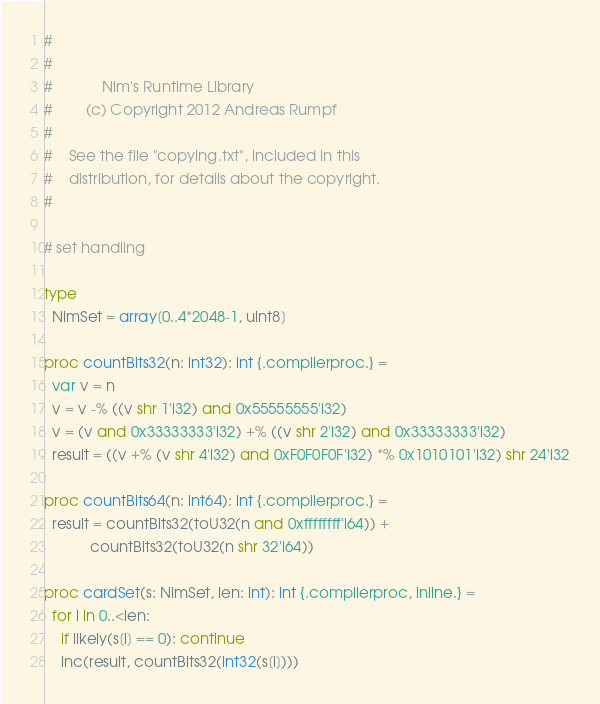Convert code to text. <code><loc_0><loc_0><loc_500><loc_500><_Nim_>#
#
#            Nim's Runtime Library
#        (c) Copyright 2012 Andreas Rumpf
#
#    See the file "copying.txt", included in this
#    distribution, for details about the copyright.
#

# set handling

type
  NimSet = array[0..4*2048-1, uint8]

proc countBits32(n: int32): int {.compilerproc.} =
  var v = n
  v = v -% ((v shr 1'i32) and 0x55555555'i32)
  v = (v and 0x33333333'i32) +% ((v shr 2'i32) and 0x33333333'i32)
  result = ((v +% (v shr 4'i32) and 0xF0F0F0F'i32) *% 0x1010101'i32) shr 24'i32

proc countBits64(n: int64): int {.compilerproc.} =
  result = countBits32(toU32(n and 0xffffffff'i64)) +
           countBits32(toU32(n shr 32'i64))

proc cardSet(s: NimSet, len: int): int {.compilerproc, inline.} =
  for i in 0..<len:
    if likely(s[i] == 0): continue
    inc(result, countBits32(int32(s[i])))
</code> 